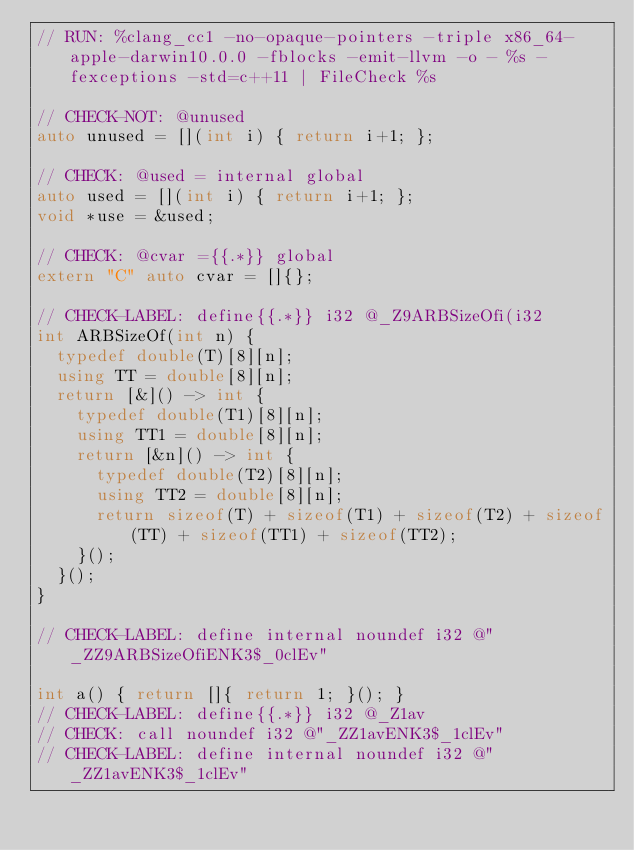<code> <loc_0><loc_0><loc_500><loc_500><_C++_>// RUN: %clang_cc1 -no-opaque-pointers -triple x86_64-apple-darwin10.0.0 -fblocks -emit-llvm -o - %s -fexceptions -std=c++11 | FileCheck %s

// CHECK-NOT: @unused
auto unused = [](int i) { return i+1; };

// CHECK: @used = internal global
auto used = [](int i) { return i+1; };
void *use = &used;

// CHECK: @cvar ={{.*}} global
extern "C" auto cvar = []{};

// CHECK-LABEL: define{{.*}} i32 @_Z9ARBSizeOfi(i32
int ARBSizeOf(int n) {
  typedef double(T)[8][n];
  using TT = double[8][n];
  return [&]() -> int {
    typedef double(T1)[8][n];
    using TT1 = double[8][n];
    return [&n]() -> int {
      typedef double(T2)[8][n];
      using TT2 = double[8][n];
      return sizeof(T) + sizeof(T1) + sizeof(T2) + sizeof(TT) + sizeof(TT1) + sizeof(TT2);
    }();
  }();
}

// CHECK-LABEL: define internal noundef i32 @"_ZZ9ARBSizeOfiENK3$_0clEv"

int a() { return []{ return 1; }(); }
// CHECK-LABEL: define{{.*}} i32 @_Z1av
// CHECK: call noundef i32 @"_ZZ1avENK3$_1clEv"
// CHECK-LABEL: define internal noundef i32 @"_ZZ1avENK3$_1clEv"</code> 